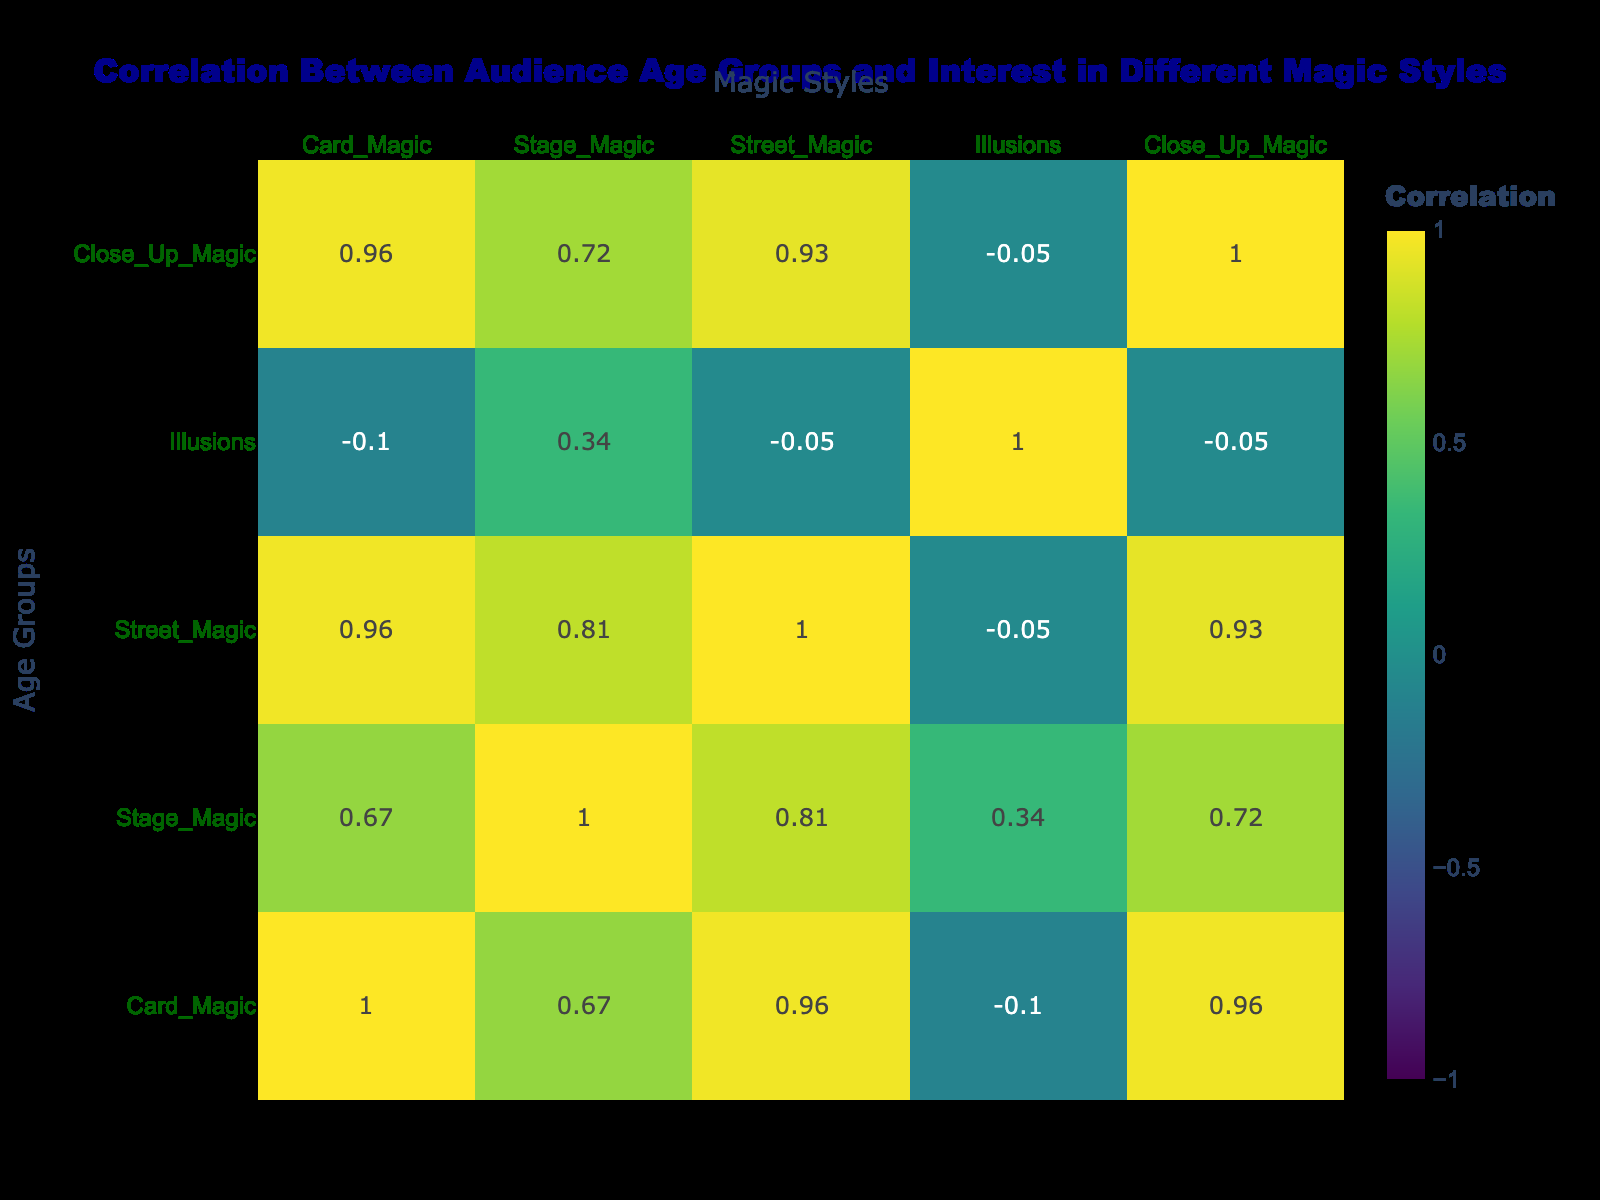What is the correlation between the age group 10-15 and Close Up Magic? By looking at the table, we can see that the age group 10-15 has a value of 9 for Close Up Magic. This is a direct retrieval question, and the information is clearly presented in the respective cell of the table.
Answer: 9 Which age group shows the highest interest in Stage Magic? Observing the table, the highest value for Stage Magic is found in the age group 16-24, with a value of 9. This is a straightforward retrieval question based on the provided data.
Answer: 16-24 What is the average interest in Illusions across all age groups? To calculate the average, we sum the values for Illusions across all age groups: (5 + 6 + 7 + 8 + 9 + 6 + 5) = 46. There are 7 age groups, so the average interest is 46/7 = 6.57. This involves a compositional step of both summation and averaging.
Answer: 6.57 Is the interest in Card Magic greater for any age group than in Street Magic? We need to compare the values for Card Magic and Street Magic for each group. Upon examination, the age group 10-15 has a value of 8 for Card Magic and 7 for Street Magic, making the statement true. This requires checking multiple data points for a true or false conclusion.
Answer: Yes What is the difference in interest between Stage Magic and Illusions for the age group 35-44? For the age group 35-44, the value for Stage Magic is 8 and for Illusions is 8 as well. The difference between these two values is 8 - 8 = 0, making it an easy calculation for comparative analysis.
Answer: 0 Which age group exhibits the least interest in Street Magic? The age group 65+ has the lowest value for Street Magic, which is 2, according to the data presented in the table. This is a simple retrieval question based on observation.
Answer: 65+ What is the total interest in all magic styles for age group 45-54? To find the total interest for age group 45-54, we sum all the values: (4 + 6 + 4 + 9 + 5) = 28. This requires working through all columns for that specific age group and performing a summation.
Answer: 28 Is Close Up Magic more popular than Illusions among the age group 25-34? For age group 25-34, the values are 6 for Close Up Magic and 7 for Illusions, respectively. Thus, Close Up Magic is not more popular than Illusions, making this statement false. This verifies two numbers to reach a logical conclusion.
Answer: No 